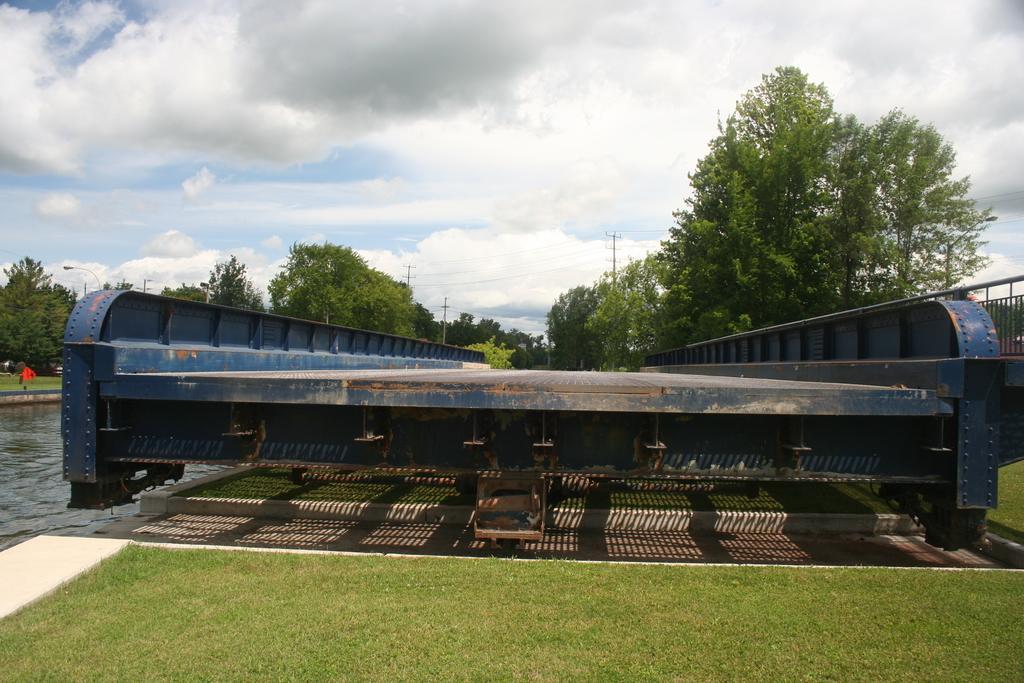Can you describe this image briefly? In the picture I can see an iron object and there is a greenery ground beside it and there is water in the left corner and there are trees in the background and the sky is a bit cloudy. 